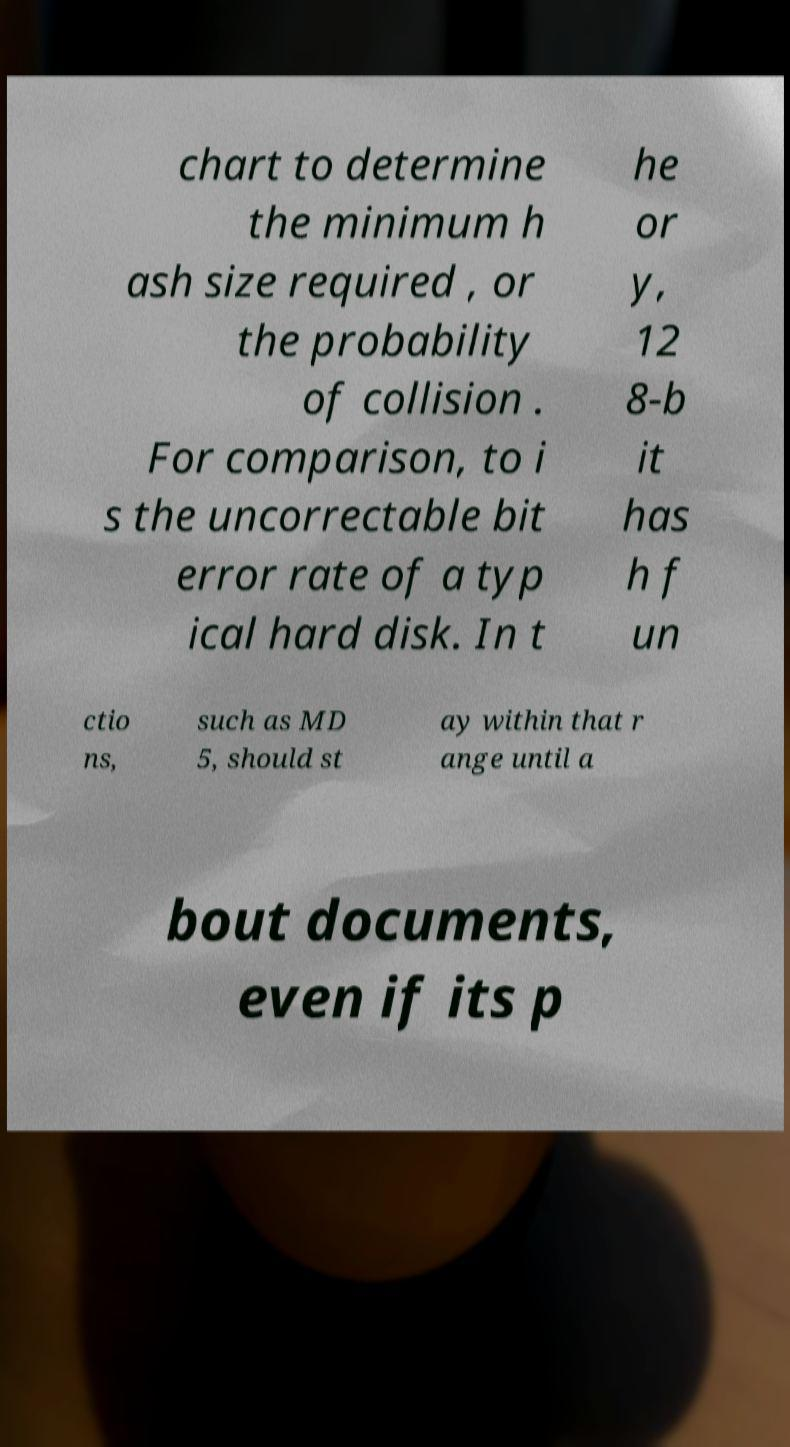Please identify and transcribe the text found in this image. chart to determine the minimum h ash size required , or the probability of collision . For comparison, to i s the uncorrectable bit error rate of a typ ical hard disk. In t he or y, 12 8-b it has h f un ctio ns, such as MD 5, should st ay within that r ange until a bout documents, even if its p 